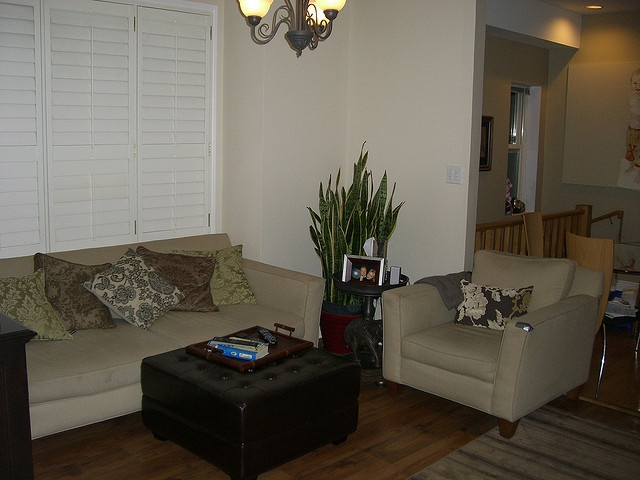Describe the objects in this image and their specific colors. I can see couch in gray, black, and darkgreen tones, chair in gray and black tones, potted plant in gray, black, darkgreen, and darkgray tones, chair in gray, black, and maroon tones, and book in gray, black, and blue tones in this image. 